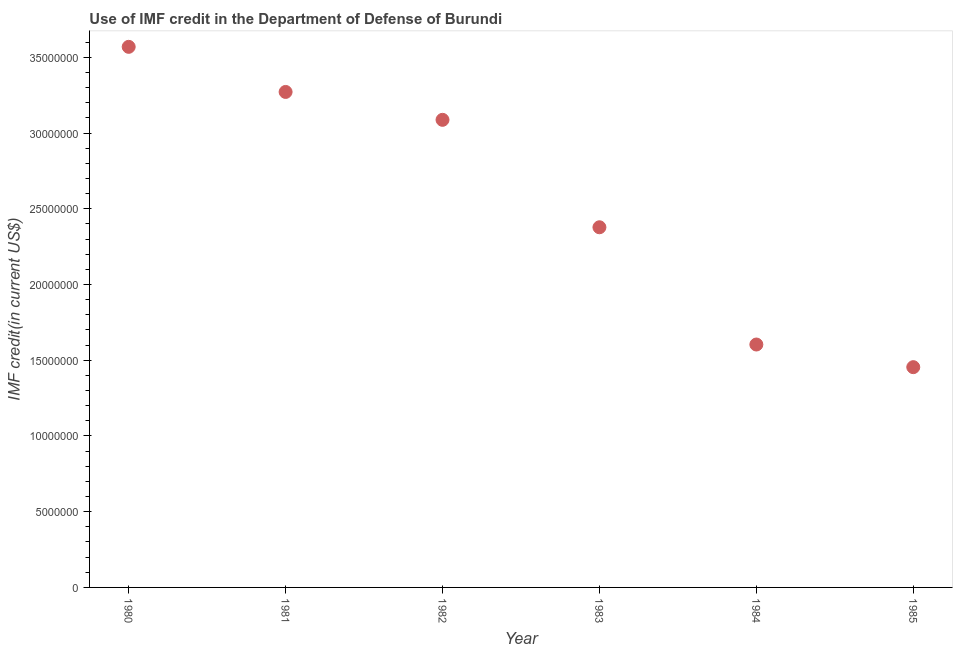What is the use of imf credit in dod in 1981?
Your answer should be very brief. 3.27e+07. Across all years, what is the maximum use of imf credit in dod?
Provide a succinct answer. 3.57e+07. Across all years, what is the minimum use of imf credit in dod?
Give a very brief answer. 1.45e+07. In which year was the use of imf credit in dod maximum?
Provide a short and direct response. 1980. In which year was the use of imf credit in dod minimum?
Offer a terse response. 1985. What is the sum of the use of imf credit in dod?
Offer a terse response. 1.54e+08. What is the difference between the use of imf credit in dod in 1980 and 1984?
Keep it short and to the point. 1.97e+07. What is the average use of imf credit in dod per year?
Keep it short and to the point. 2.56e+07. What is the median use of imf credit in dod?
Give a very brief answer. 2.73e+07. In how many years, is the use of imf credit in dod greater than 29000000 US$?
Ensure brevity in your answer.  3. Do a majority of the years between 1982 and 1980 (inclusive) have use of imf credit in dod greater than 18000000 US$?
Your answer should be compact. No. What is the ratio of the use of imf credit in dod in 1984 to that in 1985?
Your response must be concise. 1.1. Is the difference between the use of imf credit in dod in 1981 and 1984 greater than the difference between any two years?
Give a very brief answer. No. What is the difference between the highest and the second highest use of imf credit in dod?
Ensure brevity in your answer.  2.98e+06. Is the sum of the use of imf credit in dod in 1981 and 1982 greater than the maximum use of imf credit in dod across all years?
Provide a succinct answer. Yes. What is the difference between the highest and the lowest use of imf credit in dod?
Offer a very short reply. 2.11e+07. In how many years, is the use of imf credit in dod greater than the average use of imf credit in dod taken over all years?
Provide a succinct answer. 3. Does the use of imf credit in dod monotonically increase over the years?
Offer a very short reply. No. How many dotlines are there?
Keep it short and to the point. 1. Does the graph contain grids?
Your answer should be very brief. No. What is the title of the graph?
Offer a terse response. Use of IMF credit in the Department of Defense of Burundi. What is the label or title of the X-axis?
Ensure brevity in your answer.  Year. What is the label or title of the Y-axis?
Provide a succinct answer. IMF credit(in current US$). What is the IMF credit(in current US$) in 1980?
Give a very brief answer. 3.57e+07. What is the IMF credit(in current US$) in 1981?
Your answer should be compact. 3.27e+07. What is the IMF credit(in current US$) in 1982?
Your answer should be very brief. 3.09e+07. What is the IMF credit(in current US$) in 1983?
Your answer should be compact. 2.38e+07. What is the IMF credit(in current US$) in 1984?
Your response must be concise. 1.60e+07. What is the IMF credit(in current US$) in 1985?
Ensure brevity in your answer.  1.45e+07. What is the difference between the IMF credit(in current US$) in 1980 and 1981?
Provide a succinct answer. 2.98e+06. What is the difference between the IMF credit(in current US$) in 1980 and 1982?
Your response must be concise. 4.82e+06. What is the difference between the IMF credit(in current US$) in 1980 and 1983?
Provide a succinct answer. 1.19e+07. What is the difference between the IMF credit(in current US$) in 1980 and 1984?
Offer a terse response. 1.97e+07. What is the difference between the IMF credit(in current US$) in 1980 and 1985?
Your answer should be very brief. 2.11e+07. What is the difference between the IMF credit(in current US$) in 1981 and 1982?
Your response must be concise. 1.84e+06. What is the difference between the IMF credit(in current US$) in 1981 and 1983?
Make the answer very short. 8.93e+06. What is the difference between the IMF credit(in current US$) in 1981 and 1984?
Ensure brevity in your answer.  1.67e+07. What is the difference between the IMF credit(in current US$) in 1981 and 1985?
Keep it short and to the point. 1.82e+07. What is the difference between the IMF credit(in current US$) in 1982 and 1983?
Offer a very short reply. 7.09e+06. What is the difference between the IMF credit(in current US$) in 1982 and 1984?
Offer a very short reply. 1.48e+07. What is the difference between the IMF credit(in current US$) in 1982 and 1985?
Keep it short and to the point. 1.63e+07. What is the difference between the IMF credit(in current US$) in 1983 and 1984?
Offer a terse response. 7.74e+06. What is the difference between the IMF credit(in current US$) in 1983 and 1985?
Provide a succinct answer. 9.24e+06. What is the difference between the IMF credit(in current US$) in 1984 and 1985?
Keep it short and to the point. 1.50e+06. What is the ratio of the IMF credit(in current US$) in 1980 to that in 1981?
Provide a short and direct response. 1.09. What is the ratio of the IMF credit(in current US$) in 1980 to that in 1982?
Your answer should be very brief. 1.16. What is the ratio of the IMF credit(in current US$) in 1980 to that in 1983?
Provide a short and direct response. 1.5. What is the ratio of the IMF credit(in current US$) in 1980 to that in 1984?
Keep it short and to the point. 2.23. What is the ratio of the IMF credit(in current US$) in 1980 to that in 1985?
Ensure brevity in your answer.  2.45. What is the ratio of the IMF credit(in current US$) in 1981 to that in 1982?
Give a very brief answer. 1.06. What is the ratio of the IMF credit(in current US$) in 1981 to that in 1983?
Your response must be concise. 1.38. What is the ratio of the IMF credit(in current US$) in 1981 to that in 1984?
Your answer should be compact. 2.04. What is the ratio of the IMF credit(in current US$) in 1981 to that in 1985?
Provide a short and direct response. 2.25. What is the ratio of the IMF credit(in current US$) in 1982 to that in 1983?
Offer a terse response. 1.3. What is the ratio of the IMF credit(in current US$) in 1982 to that in 1984?
Offer a terse response. 1.93. What is the ratio of the IMF credit(in current US$) in 1982 to that in 1985?
Ensure brevity in your answer.  2.12. What is the ratio of the IMF credit(in current US$) in 1983 to that in 1984?
Offer a terse response. 1.48. What is the ratio of the IMF credit(in current US$) in 1983 to that in 1985?
Offer a very short reply. 1.64. What is the ratio of the IMF credit(in current US$) in 1984 to that in 1985?
Your answer should be very brief. 1.1. 